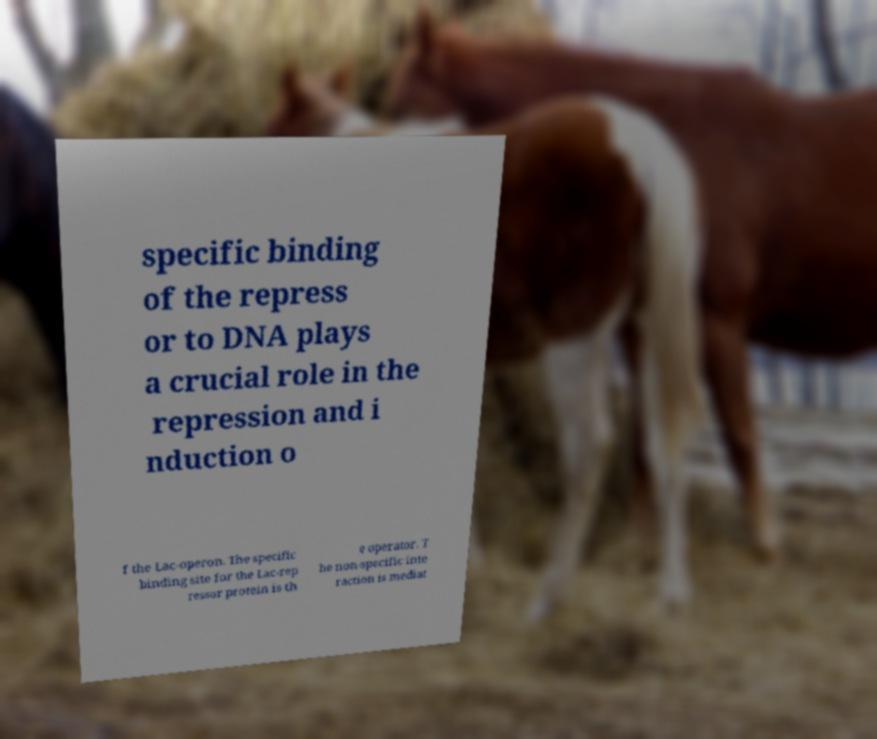Could you assist in decoding the text presented in this image and type it out clearly? specific binding of the repress or to DNA plays a crucial role in the repression and i nduction o f the Lac-operon. The specific binding site for the Lac-rep ressor protein is th e operator. T he non-specific inte raction is mediat 